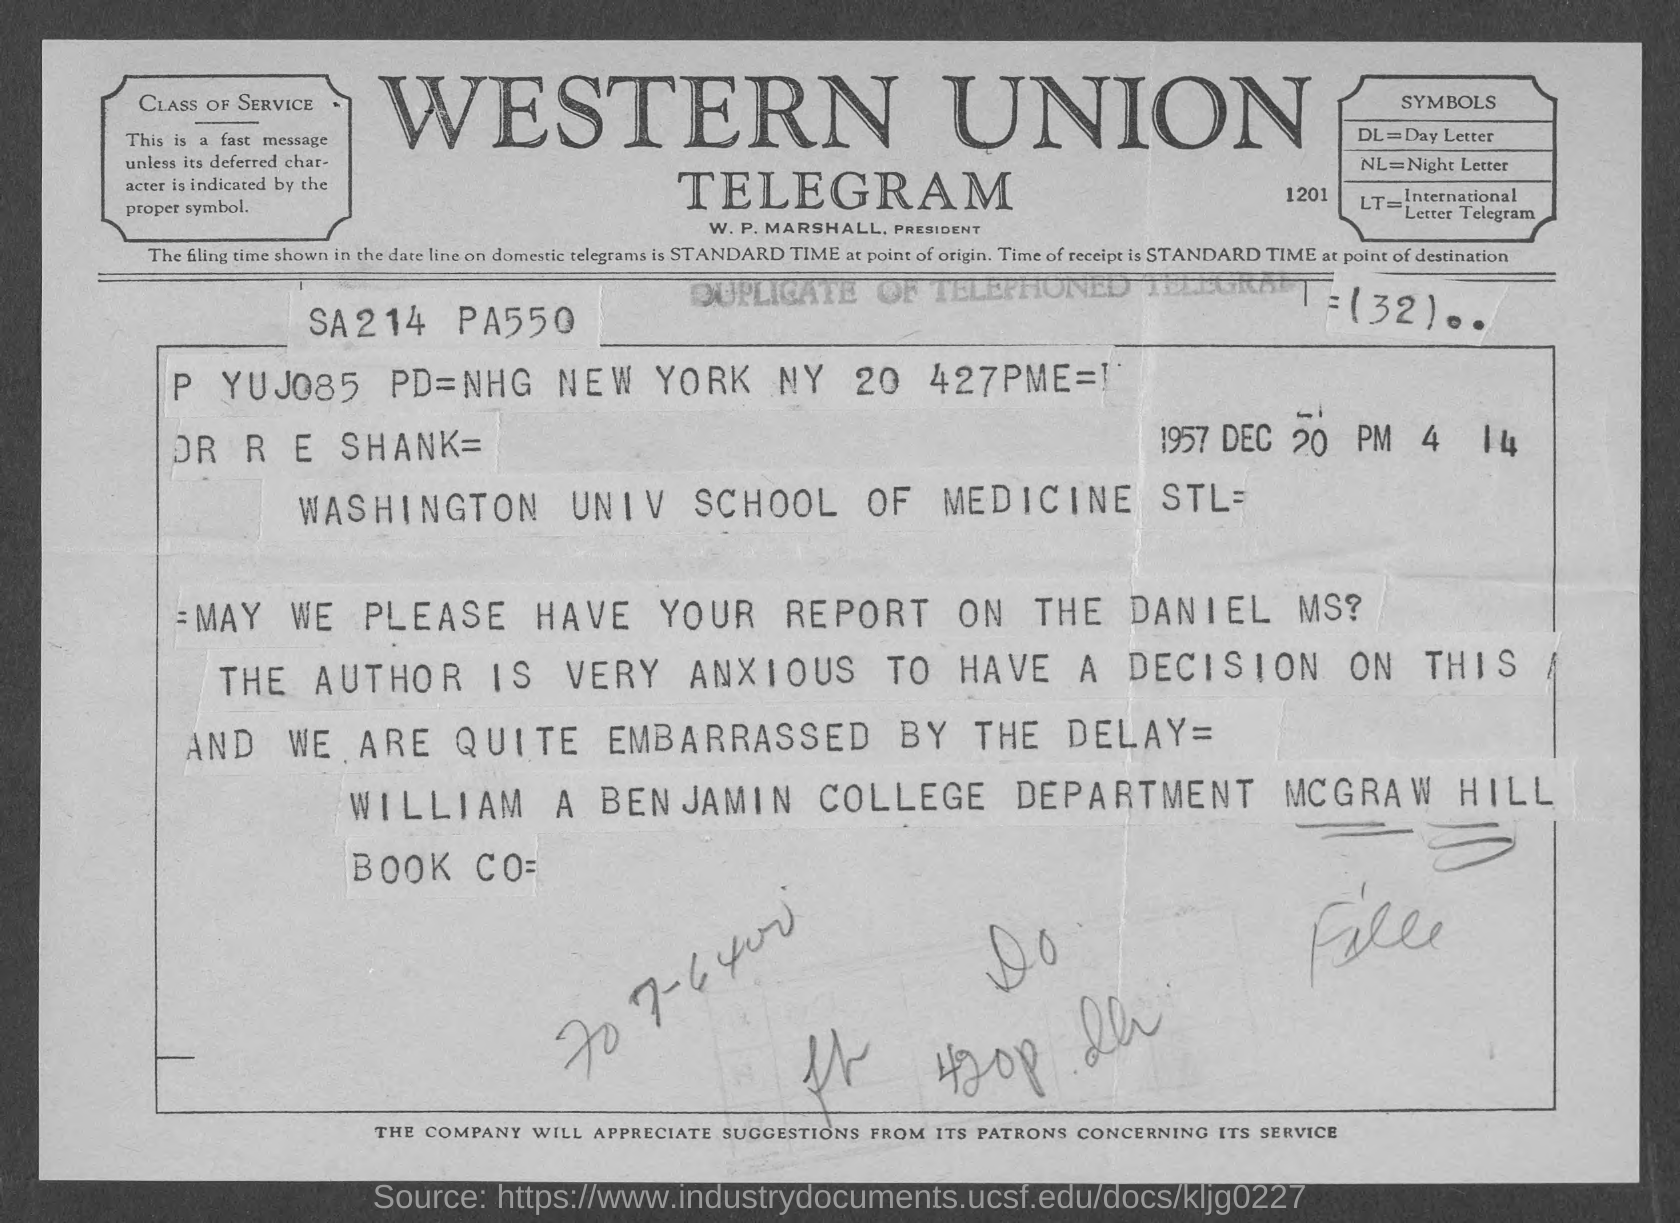Indicate a few pertinent items in this graphic. DL stands for Day Letter. The sender of this letter is William A Benjamin. What does LT stand for?" "It stands for International Letter Telegram. The document indicates a date of December 20, 1957. 